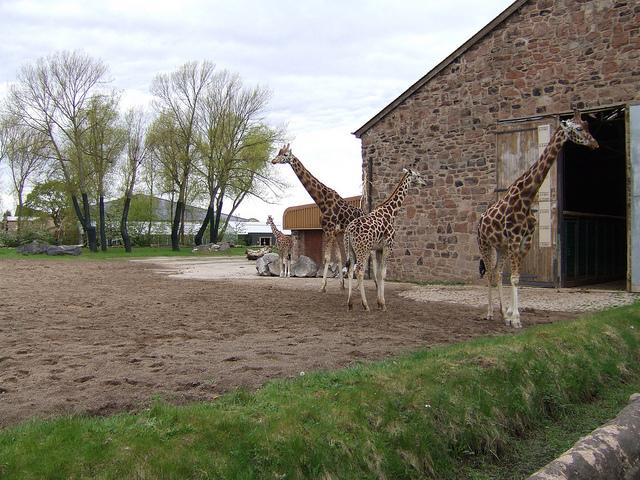What type of animal is shown?

Choices:
A) domestic
B) aquatic
C) nocturnal
D) wild wild 